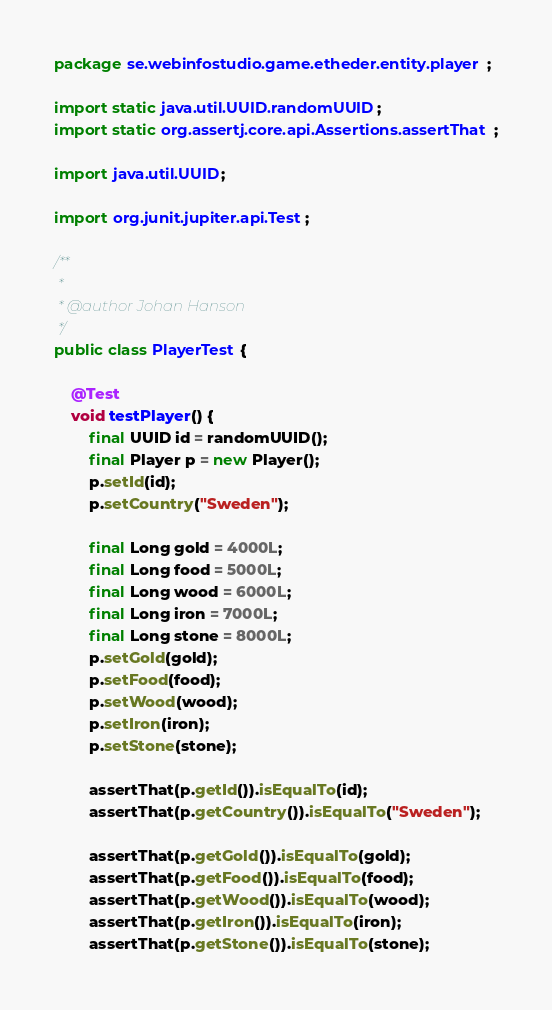Convert code to text. <code><loc_0><loc_0><loc_500><loc_500><_Java_>package se.webinfostudio.game.etheder.entity.player;

import static java.util.UUID.randomUUID;
import static org.assertj.core.api.Assertions.assertThat;

import java.util.UUID;

import org.junit.jupiter.api.Test;

/**
 *
 * @author Johan Hanson
 */
public class PlayerTest {

	@Test
	void testPlayer() {
		final UUID id = randomUUID();
		final Player p = new Player();
		p.setId(id);
		p.setCountry("Sweden");

		final Long gold = 4000L;
		final Long food = 5000L;
		final Long wood = 6000L;
		final Long iron = 7000L;
		final Long stone = 8000L;
		p.setGold(gold);
		p.setFood(food);
		p.setWood(wood);
		p.setIron(iron);
		p.setStone(stone);

		assertThat(p.getId()).isEqualTo(id);
		assertThat(p.getCountry()).isEqualTo("Sweden");

		assertThat(p.getGold()).isEqualTo(gold);
		assertThat(p.getFood()).isEqualTo(food);
		assertThat(p.getWood()).isEqualTo(wood);
		assertThat(p.getIron()).isEqualTo(iron);
		assertThat(p.getStone()).isEqualTo(stone);</code> 